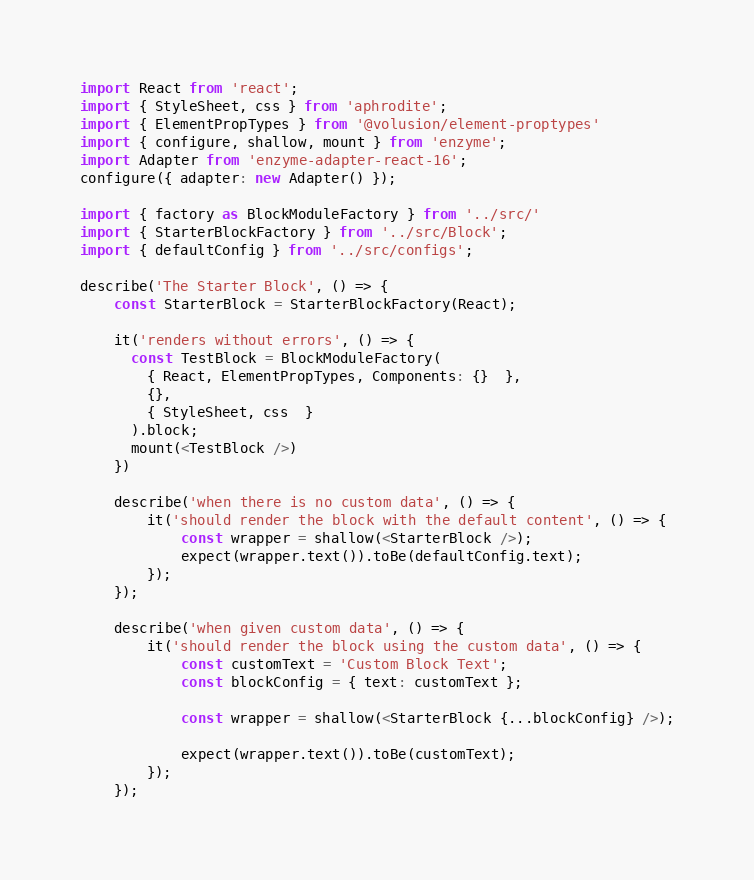Convert code to text. <code><loc_0><loc_0><loc_500><loc_500><_JavaScript_>import React from 'react';
import { StyleSheet, css } from 'aphrodite';
import { ElementPropTypes } from '@volusion/element-proptypes'
import { configure, shallow, mount } from 'enzyme';
import Adapter from 'enzyme-adapter-react-16';
configure({ adapter: new Adapter() });

import { factory as BlockModuleFactory } from '../src/'
import { StarterBlockFactory } from '../src/Block';
import { defaultConfig } from '../src/configs';

describe('The Starter Block', () => {
    const StarterBlock = StarterBlockFactory(React);

    it('renders without errors', () => {
      const TestBlock = BlockModuleFactory(
        { React, ElementPropTypes, Components: {}  },
        {},
        { StyleSheet, css  }
      ).block;
      mount(<TestBlock />)
    })

    describe('when there is no custom data', () => {
        it('should render the block with the default content', () => {
            const wrapper = shallow(<StarterBlock />);
            expect(wrapper.text()).toBe(defaultConfig.text);
        });
    });

    describe('when given custom data', () => {
        it('should render the block using the custom data', () => {
            const customText = 'Custom Block Text';
            const blockConfig = { text: customText };

            const wrapper = shallow(<StarterBlock {...blockConfig} />);

            expect(wrapper.text()).toBe(customText);
        });
    });</code> 